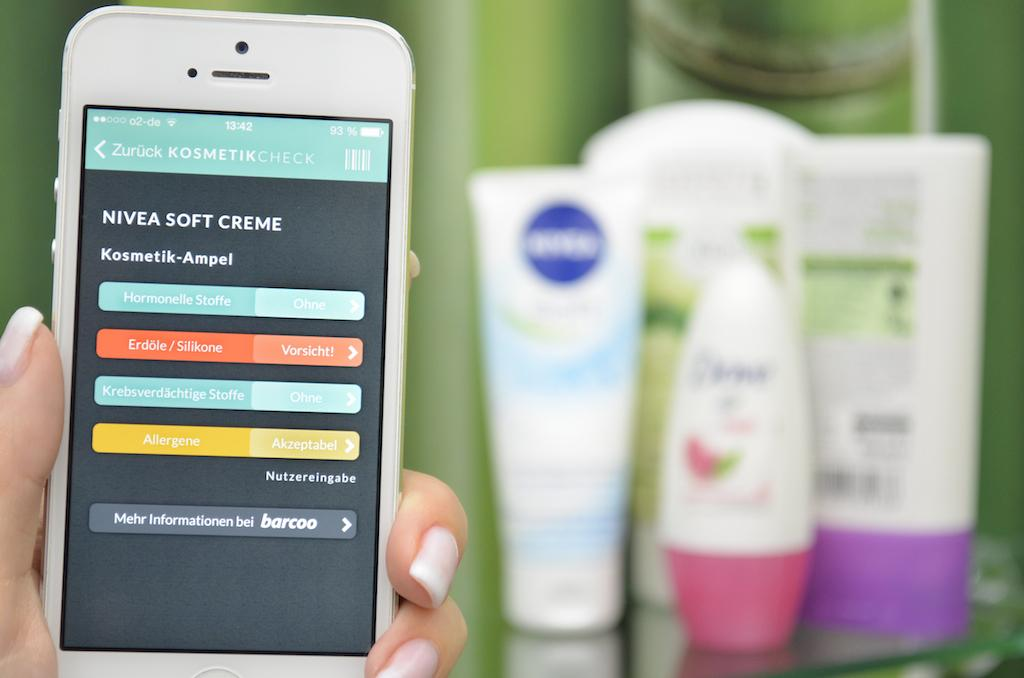What is the human hand holding in the image? The human hand is holding a phone in the image. What else can be seen in the image besides the hand and phone? There are bottles in the image. What type of hat is being distributed by the van in the image? There is no van or hat present in the image; it only features a human hand holding a phone and bottles. 